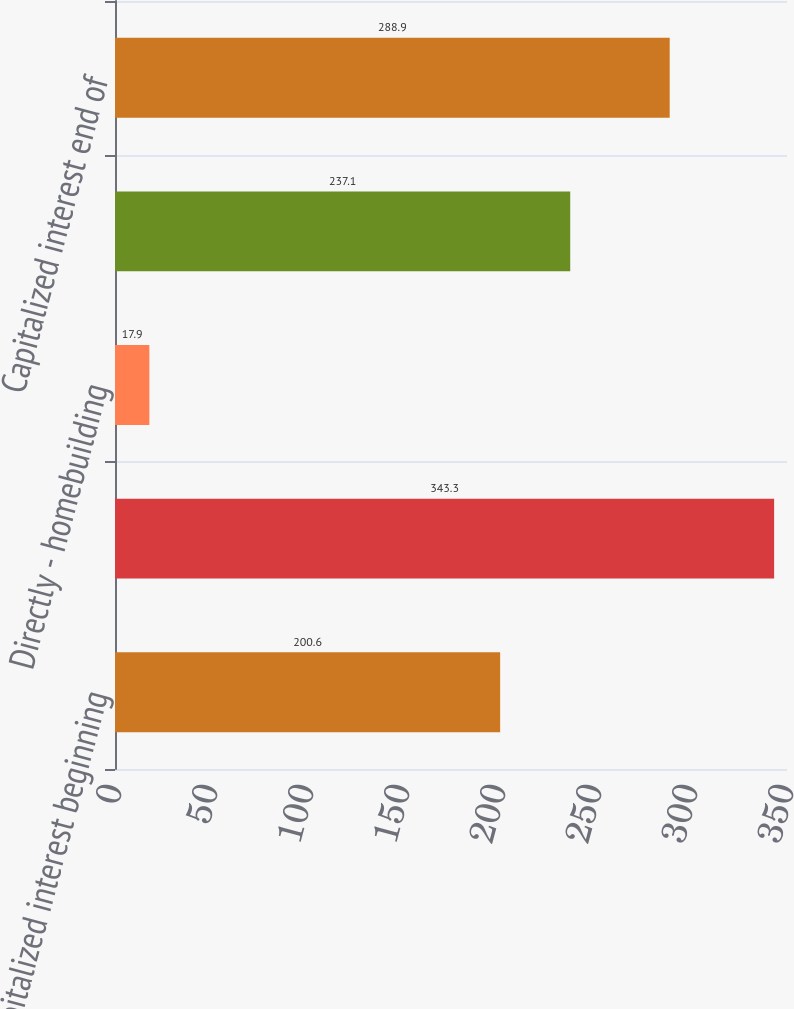<chart> <loc_0><loc_0><loc_500><loc_500><bar_chart><fcel>Capitalized interest beginning<fcel>Interest incurred -<fcel>Directly - homebuilding<fcel>Amortized to cost of sales<fcel>Capitalized interest end of<nl><fcel>200.6<fcel>343.3<fcel>17.9<fcel>237.1<fcel>288.9<nl></chart> 